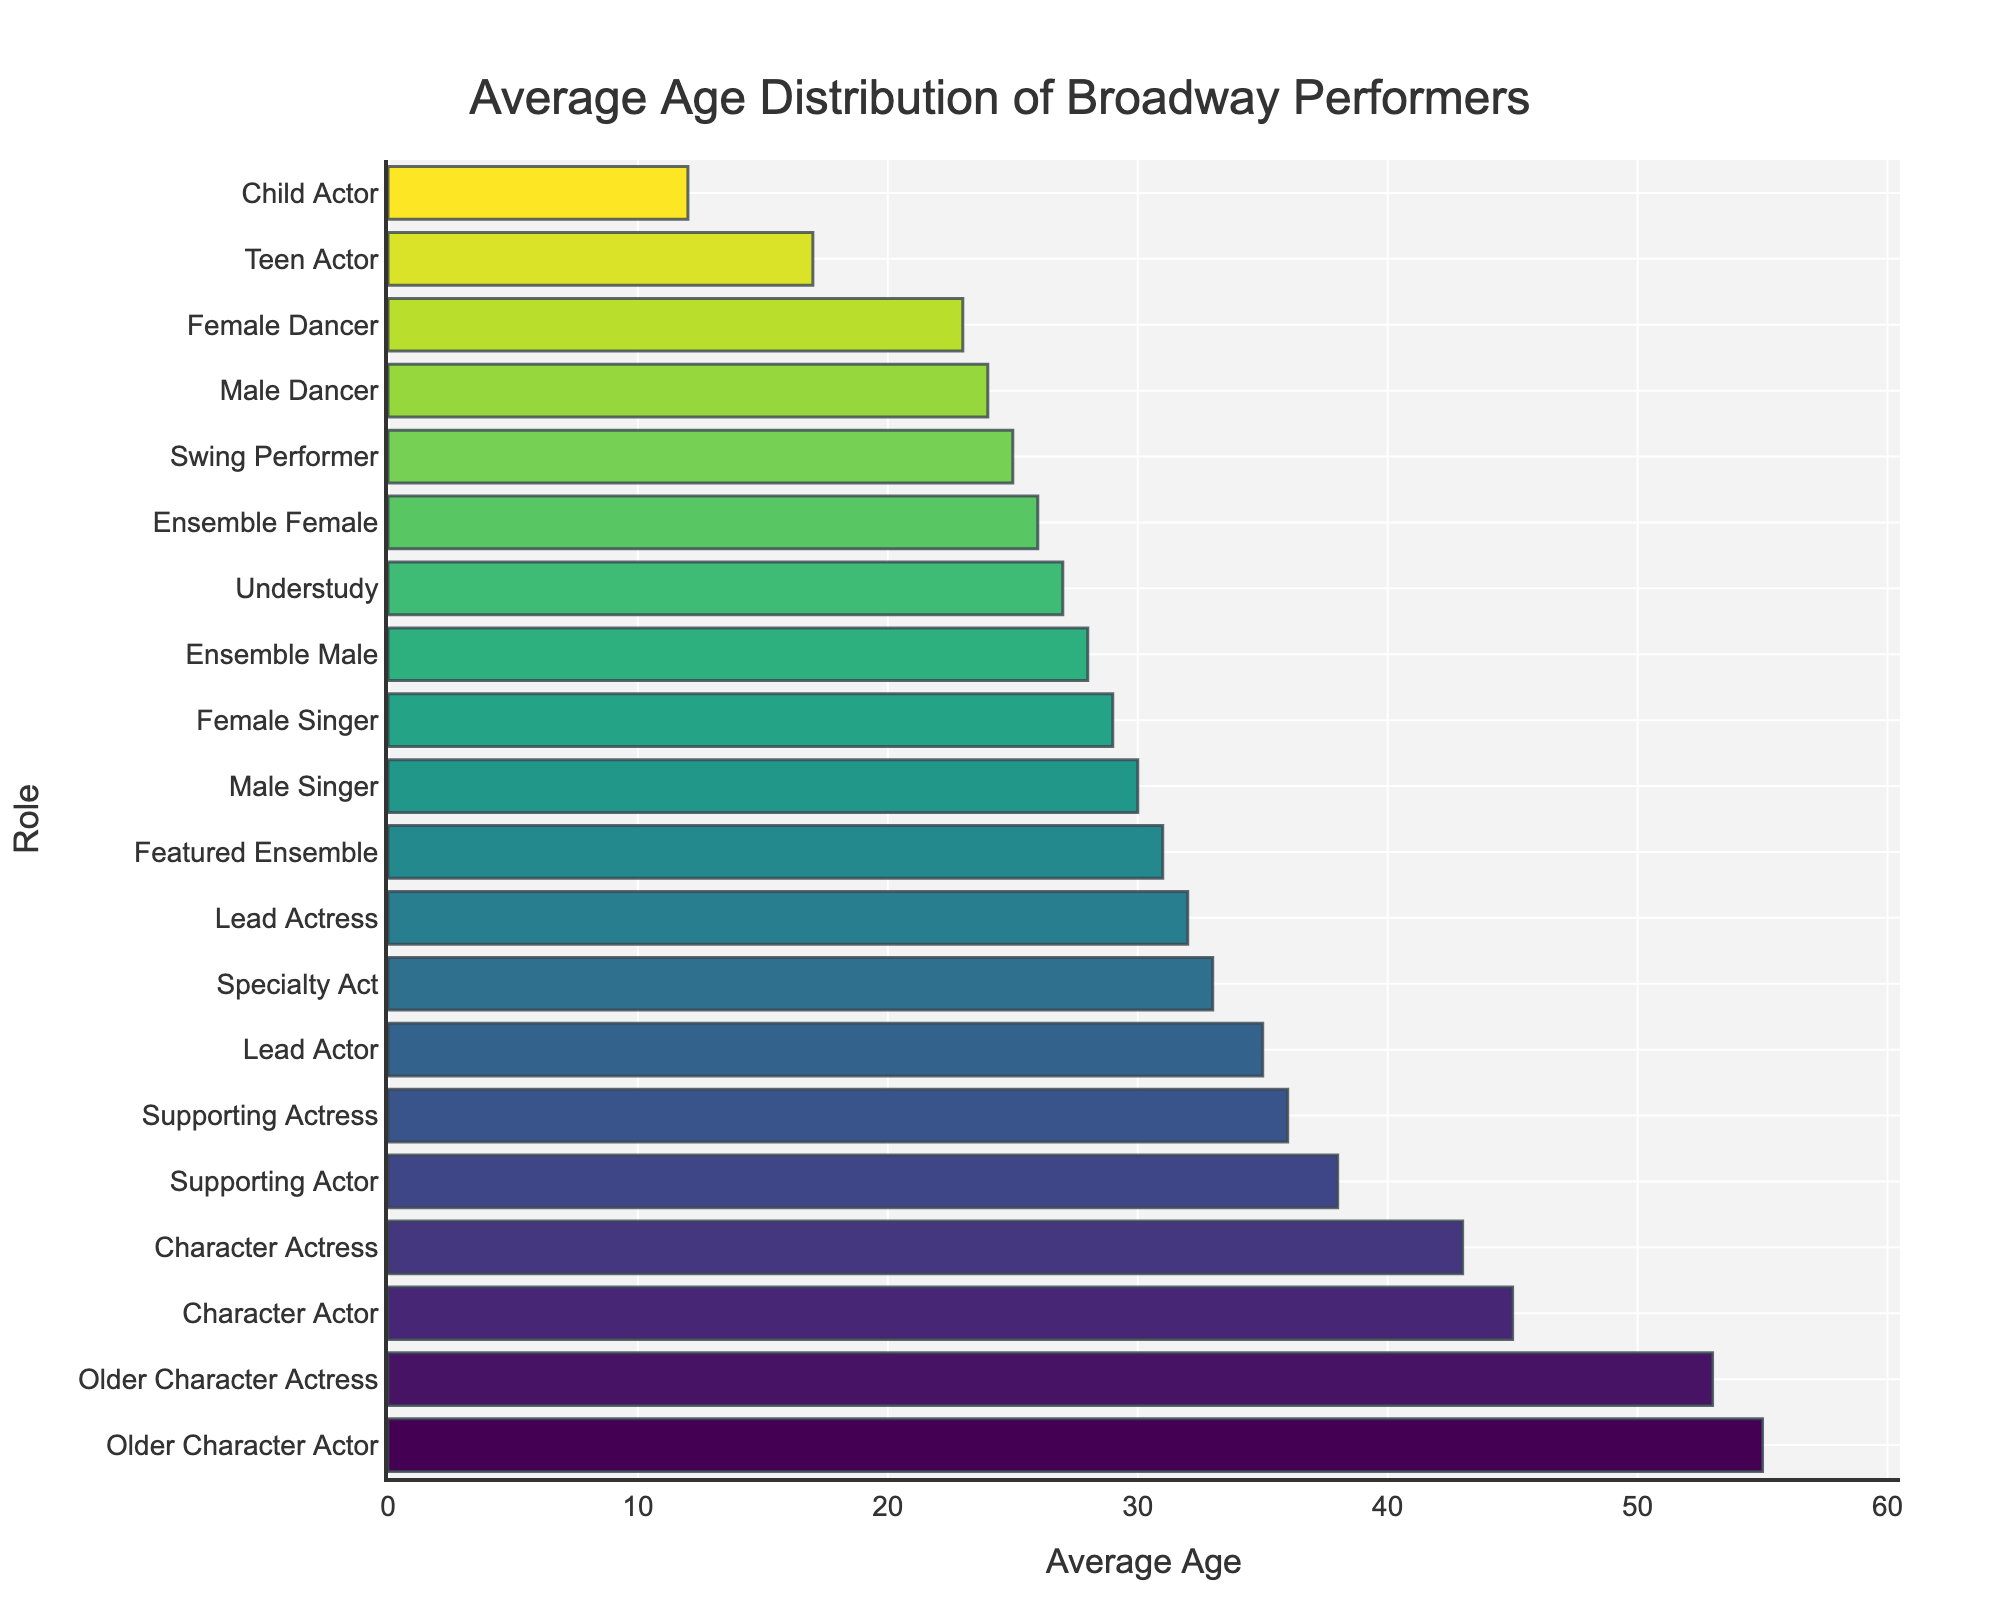What role has the highest average age on Broadway? The figure shows the average age for each role with the roles sorted by average age. The highest bar corresponds to the "Older Character Actor" role.
Answer: Older Character Actor What is the difference in average age between Lead Actor and Lead Actress roles? The average age for Lead Actor is 35 and for Lead Actress is 32. The difference is calculated as 35 - 32 = 3.
Answer: 3 Which role has the lowest average age on Broadway? The figure shows the average age for each role with the roles sorted by average age. The shortest bar corresponds to the "Child Actor" role.
Answer: Child Actor How does the average age of Ensemble Male compare to Ensemble Female performers? The average age of Ensemble Male performers is 28, and of Ensemble Female performers is 26. The Ensemble Male performers are older.
Answer: Ensemble Male performers are older Calculate the average of the three oldest roles on Broadway. The three oldest roles are Older Character Actor (55), Older Character Actress (53), and Character Actor (45). The average is calculated as (55 + 53 + 45) / 3 = 51.
Answer: 51 What is the range of average ages for Broadway performers? The range is the difference between the highest and lowest average ages. The highest average age is 55 (Older Character Actor) and the lowest is 12 (Child Actor). The range is calculated as 55 - 12 = 43.
Answer: 43 Compare the average ages of supporting roles versus lead roles. Supporting Actor (38) and Supporting Actress (36) compared to Lead Actor (35) and Lead Actress (32). The average for supporting roles is (38 + 36) / 2 = 37, and for lead roles (35 + 32) / 2 = 33.5. Supporting roles have a higher average age.
Answer: Supporting roles have a higher average age Are there more roles with an average age below 30 or above 30? Count the number of roles with an average age below 30 and those above 30. Roles below 30: Ensemble Male (28), Ensemble Female (26), Male Dancer (24), Female Dancer (23), Male Singer (30), Female Singer (29), Understudy (27), Swing Performer (25), Child Actor (12), Teen Actor (17) = 10. Roles above 30: Lead Actor (35), Lead Actress (32), Supporting Actor (38), Supporting Actress (36), Character Actor (45), Character Actress (43), Older Character Actor (55), Older Character Actress (53), Featured Ensemble (31), Specialty Act (33) = 10. They are equal.
Answer: Equal Which role's average age is closest to 30? The figure shows several roles close to 30. The closest roles are Male Singer (30) and Female Singer (29). Male Singer is exactly 30.
Answer: Male Singer What is the median age of the roles listed? To find the median, sort all roles by age: Child Actor (12), Teen Actor (17), Female Dancer (23), Male Dancer (24), Swing Performer (25), Ensemble Female (26), Understudy (27), Ensemble Male (28), Female Singer (29), Male Singer (30), Featured Ensemble (31), Lead Actress (32), Specialty Act (33), Lead Actor (35), Supporting Actress (36), Supporting Actor (38), Character Actress (43), Character Actor (45), Older Character Actress (53), Older Character Actor (55). There are 20 roles, so the median is the average of the 10th and 11th values: (Male Singer and Featured Ensemble) = (30 + 31) / 2 = 30.5.
Answer: 30.5 